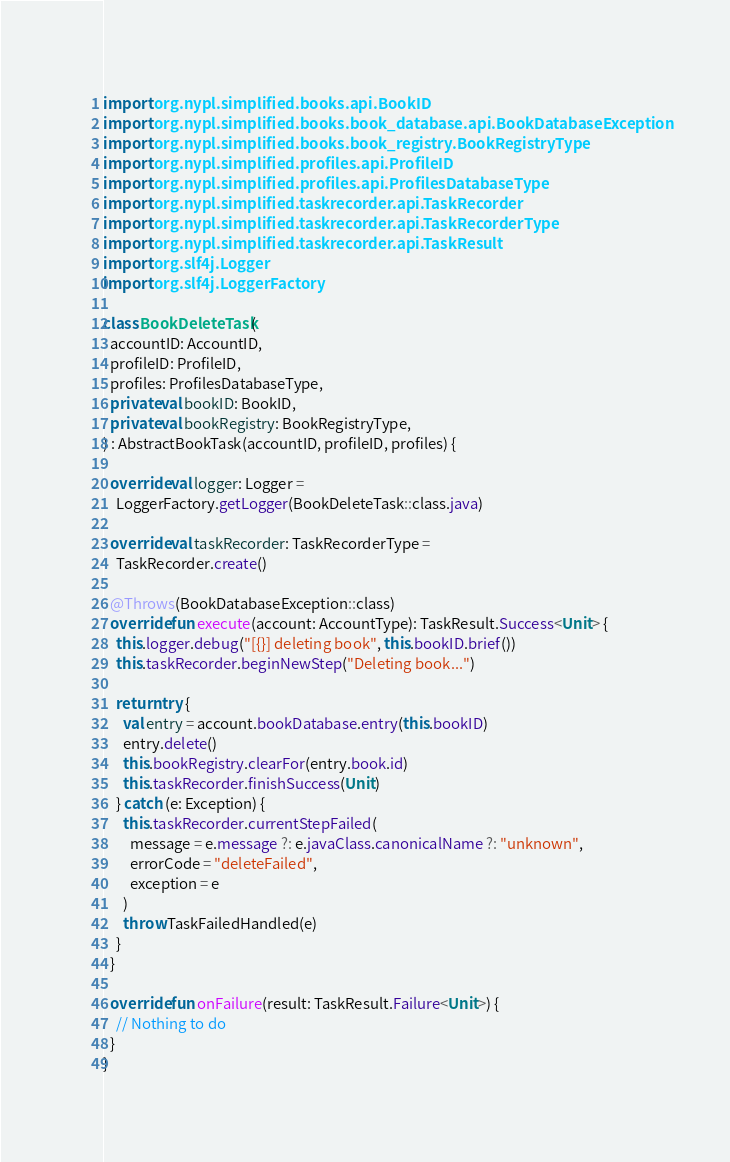<code> <loc_0><loc_0><loc_500><loc_500><_Kotlin_>import org.nypl.simplified.books.api.BookID
import org.nypl.simplified.books.book_database.api.BookDatabaseException
import org.nypl.simplified.books.book_registry.BookRegistryType
import org.nypl.simplified.profiles.api.ProfileID
import org.nypl.simplified.profiles.api.ProfilesDatabaseType
import org.nypl.simplified.taskrecorder.api.TaskRecorder
import org.nypl.simplified.taskrecorder.api.TaskRecorderType
import org.nypl.simplified.taskrecorder.api.TaskResult
import org.slf4j.Logger
import org.slf4j.LoggerFactory

class BookDeleteTask(
  accountID: AccountID,
  profileID: ProfileID,
  profiles: ProfilesDatabaseType,
  private val bookID: BookID,
  private val bookRegistry: BookRegistryType,
) : AbstractBookTask(accountID, profileID, profiles) {

  override val logger: Logger =
    LoggerFactory.getLogger(BookDeleteTask::class.java)

  override val taskRecorder: TaskRecorderType =
    TaskRecorder.create()

  @Throws(BookDatabaseException::class)
  override fun execute(account: AccountType): TaskResult.Success<Unit> {
    this.logger.debug("[{}] deleting book", this.bookID.brief())
    this.taskRecorder.beginNewStep("Deleting book...")

    return try {
      val entry = account.bookDatabase.entry(this.bookID)
      entry.delete()
      this.bookRegistry.clearFor(entry.book.id)
      this.taskRecorder.finishSuccess(Unit)
    } catch (e: Exception) {
      this.taskRecorder.currentStepFailed(
        message = e.message ?: e.javaClass.canonicalName ?: "unknown",
        errorCode = "deleteFailed",
        exception = e
      )
      throw TaskFailedHandled(e)
    }
  }

  override fun onFailure(result: TaskResult.Failure<Unit>) {
    // Nothing to do
  }
}
</code> 